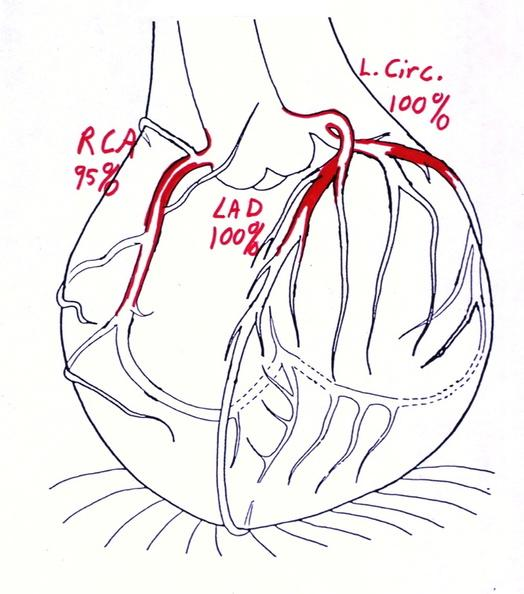where is this area in the body?
Answer the question using a single word or phrase. Heart 